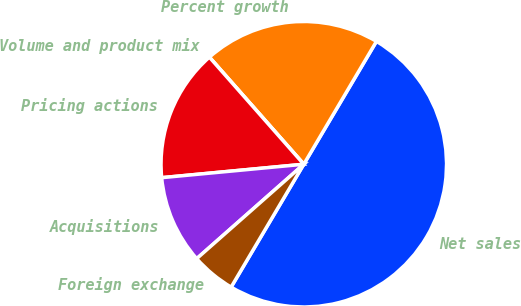<chart> <loc_0><loc_0><loc_500><loc_500><pie_chart><fcel>Net sales<fcel>Percent growth<fcel>Volume and product mix<fcel>Pricing actions<fcel>Acquisitions<fcel>Foreign exchange<nl><fcel>50.0%<fcel>20.0%<fcel>0.0%<fcel>15.0%<fcel>10.0%<fcel>5.0%<nl></chart> 